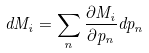Convert formula to latex. <formula><loc_0><loc_0><loc_500><loc_500>d M _ { i } = \sum _ { n } \frac { \partial M _ { i } } { \partial p _ { n } } d p _ { n }</formula> 